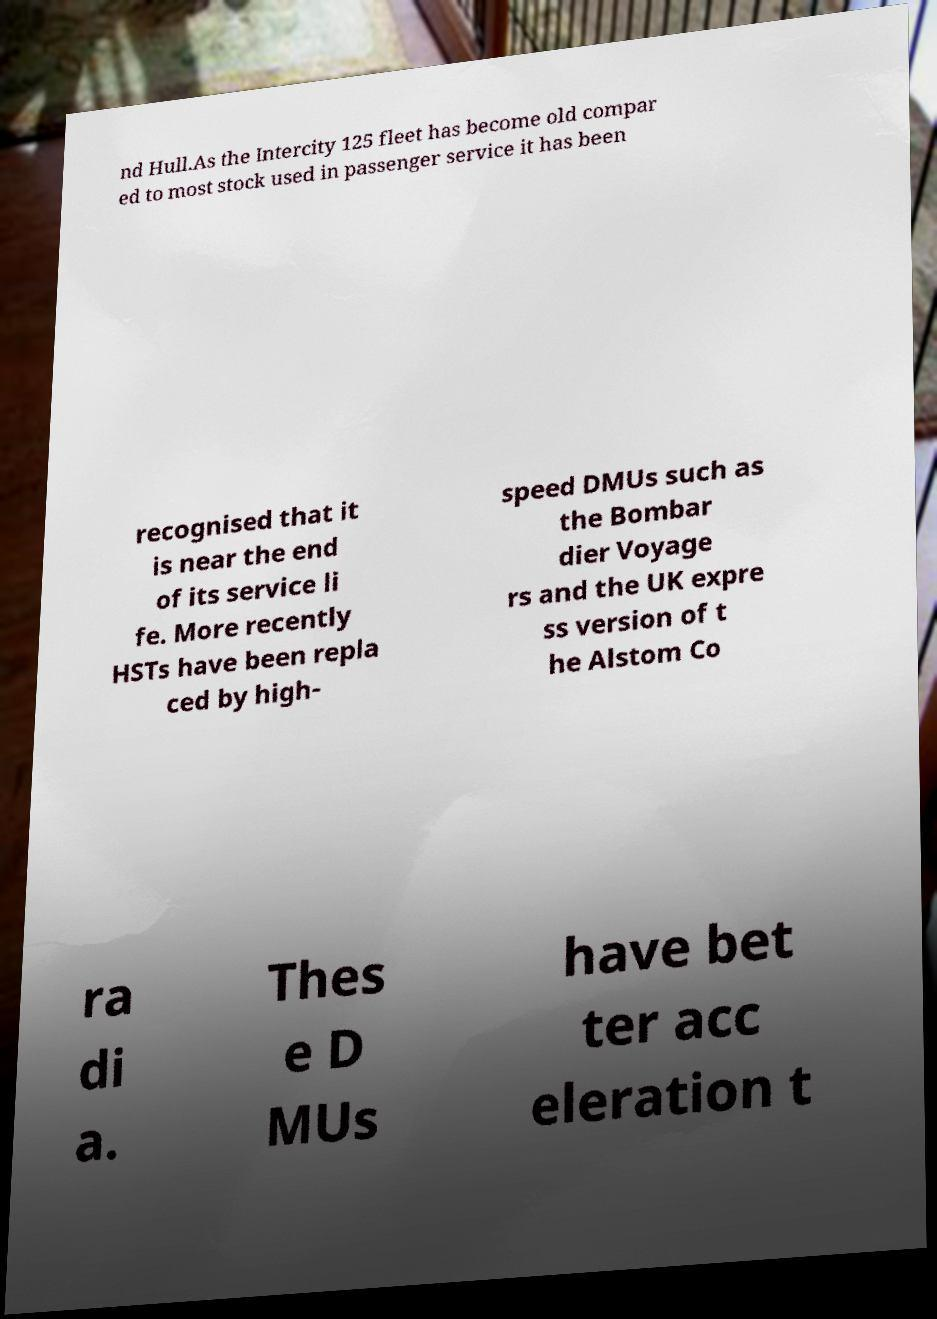Please read and relay the text visible in this image. What does it say? nd Hull.As the Intercity 125 fleet has become old compar ed to most stock used in passenger service it has been recognised that it is near the end of its service li fe. More recently HSTs have been repla ced by high- speed DMUs such as the Bombar dier Voyage rs and the UK expre ss version of t he Alstom Co ra di a. Thes e D MUs have bet ter acc eleration t 